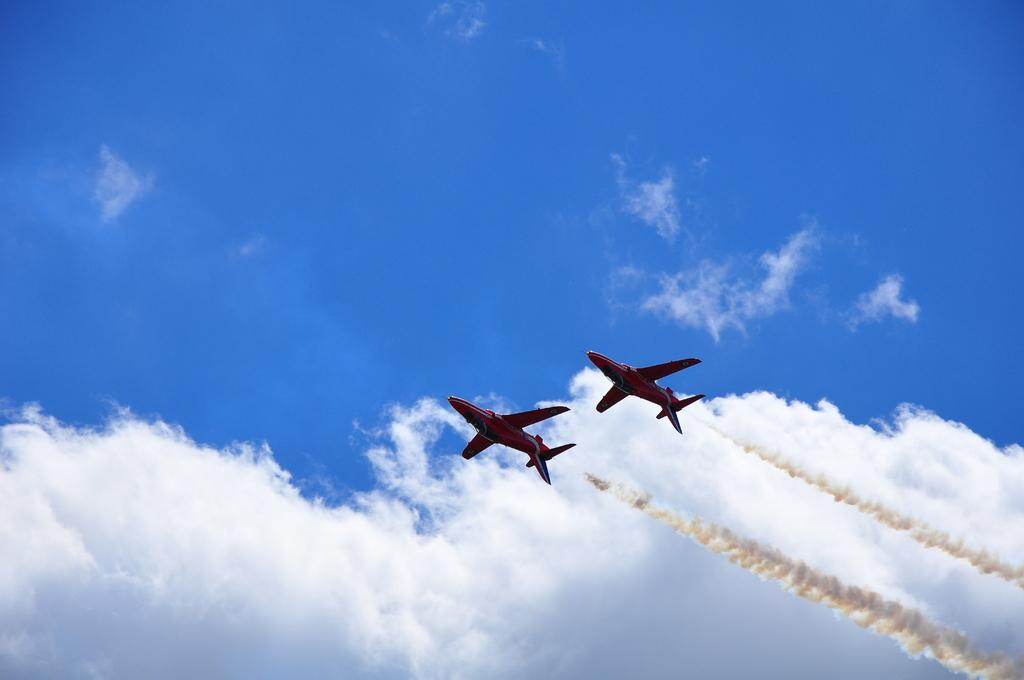How many airplanes are in the image? There are two airplanes in the image. Where are the airplanes located? The airplanes are in the air. What can be seen in the background of the image? The sky is visible in the image. What is the condition of the sky in the image? The sky appears to be cloudy. Where are the chickens located in the image? There are no chickens present in the image. What type of roof is visible on the airplanes in the image? Airplanes do not have roofs; they have wings and fuselages. 